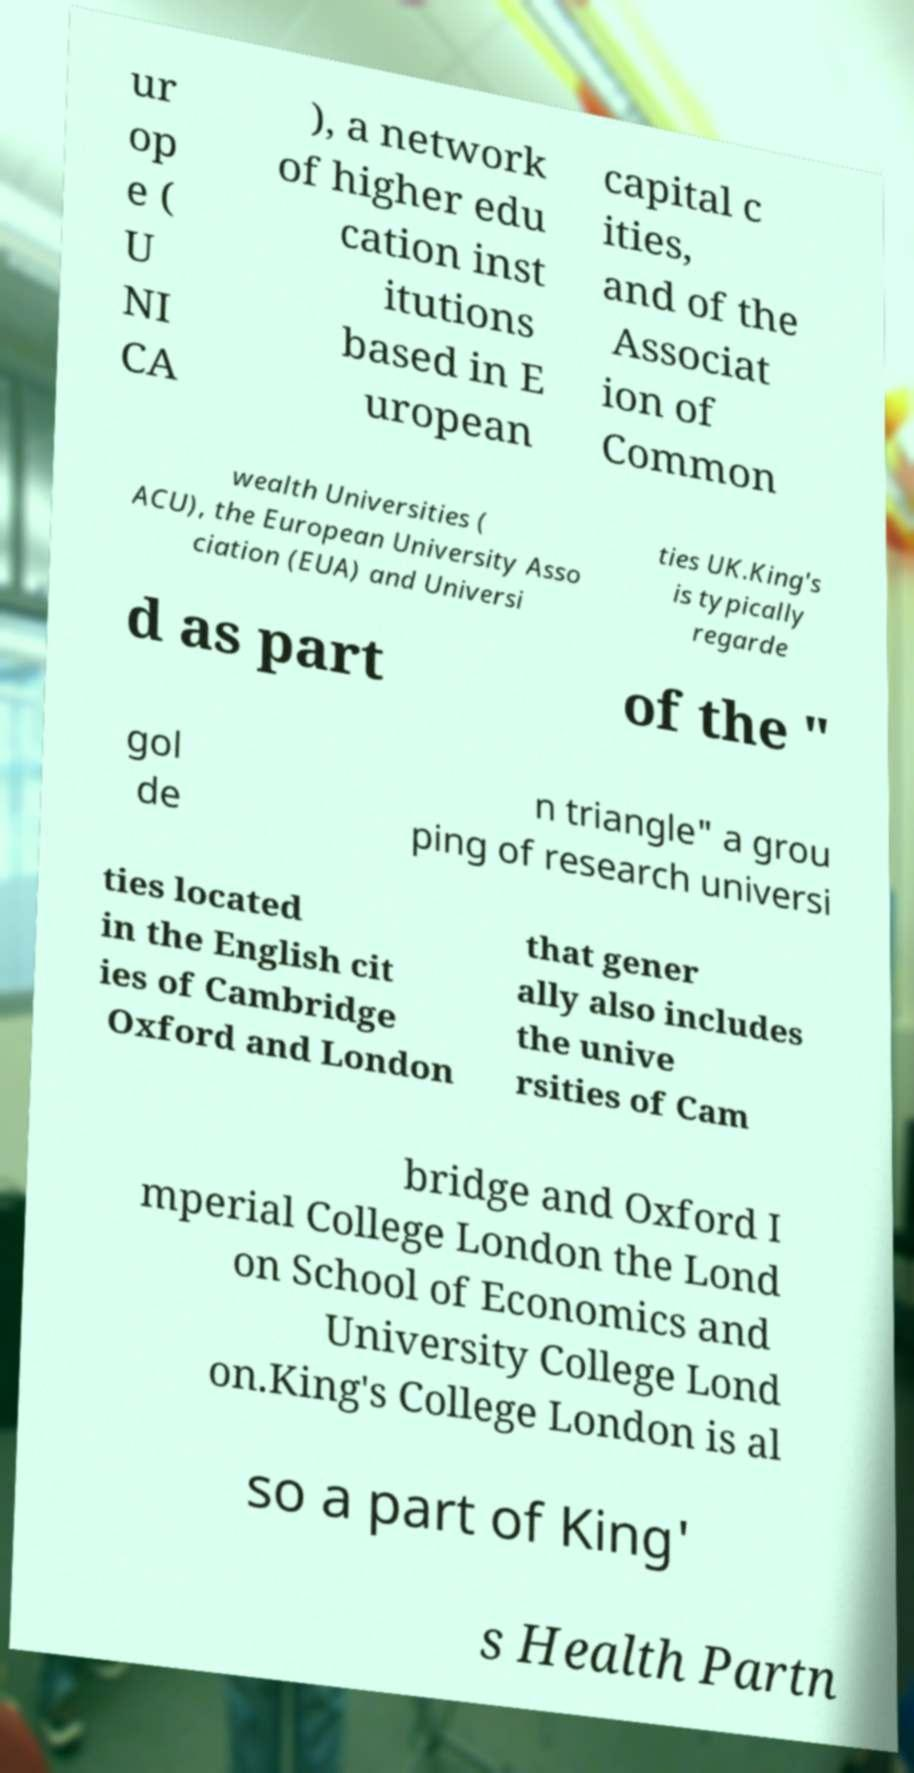There's text embedded in this image that I need extracted. Can you transcribe it verbatim? ur op e ( U NI CA ), a network of higher edu cation inst itutions based in E uropean capital c ities, and of the Associat ion of Common wealth Universities ( ACU), the European University Asso ciation (EUA) and Universi ties UK.King's is typically regarde d as part of the " gol de n triangle" a grou ping of research universi ties located in the English cit ies of Cambridge Oxford and London that gener ally also includes the unive rsities of Cam bridge and Oxford I mperial College London the Lond on School of Economics and University College Lond on.King's College London is al so a part of King' s Health Partn 